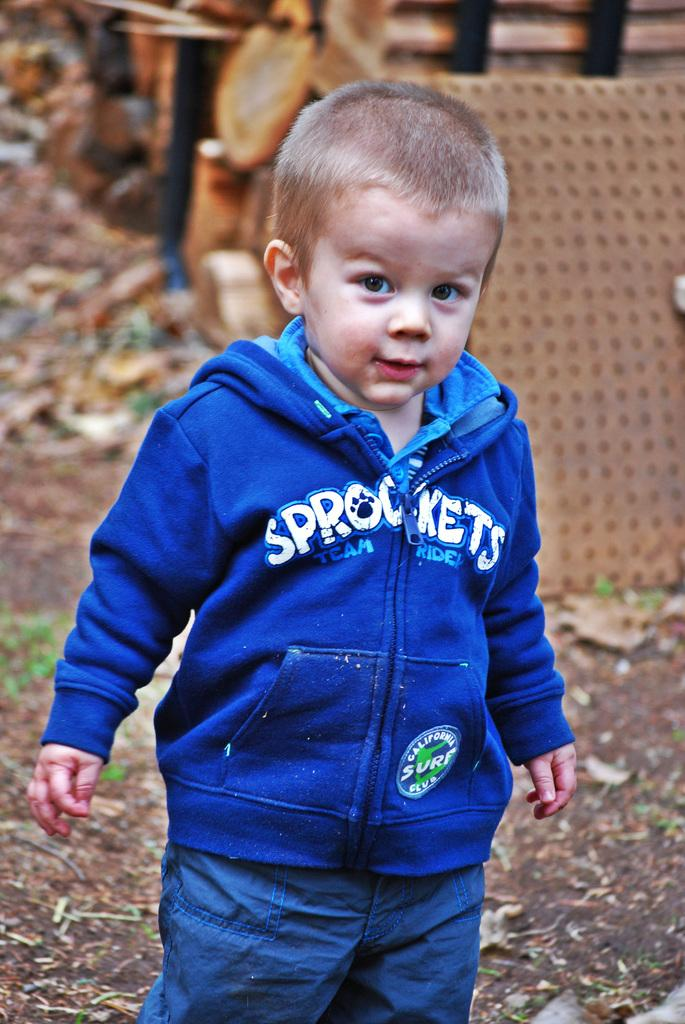Provide a one-sentence caption for the provided image. A young toddler in a blue and white Sprockets hoodie is standing in the yard. 